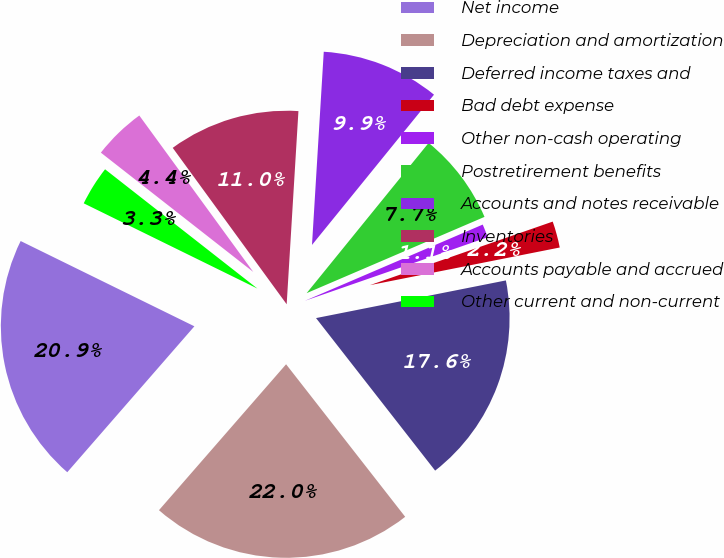<chart> <loc_0><loc_0><loc_500><loc_500><pie_chart><fcel>Net income<fcel>Depreciation and amortization<fcel>Deferred income taxes and<fcel>Bad debt expense<fcel>Other non-cash operating<fcel>Postretirement benefits<fcel>Accounts and notes receivable<fcel>Inventories<fcel>Accounts payable and accrued<fcel>Other current and non-current<nl><fcel>20.86%<fcel>21.96%<fcel>17.57%<fcel>2.21%<fcel>1.12%<fcel>7.7%<fcel>9.89%<fcel>10.99%<fcel>4.41%<fcel>3.31%<nl></chart> 